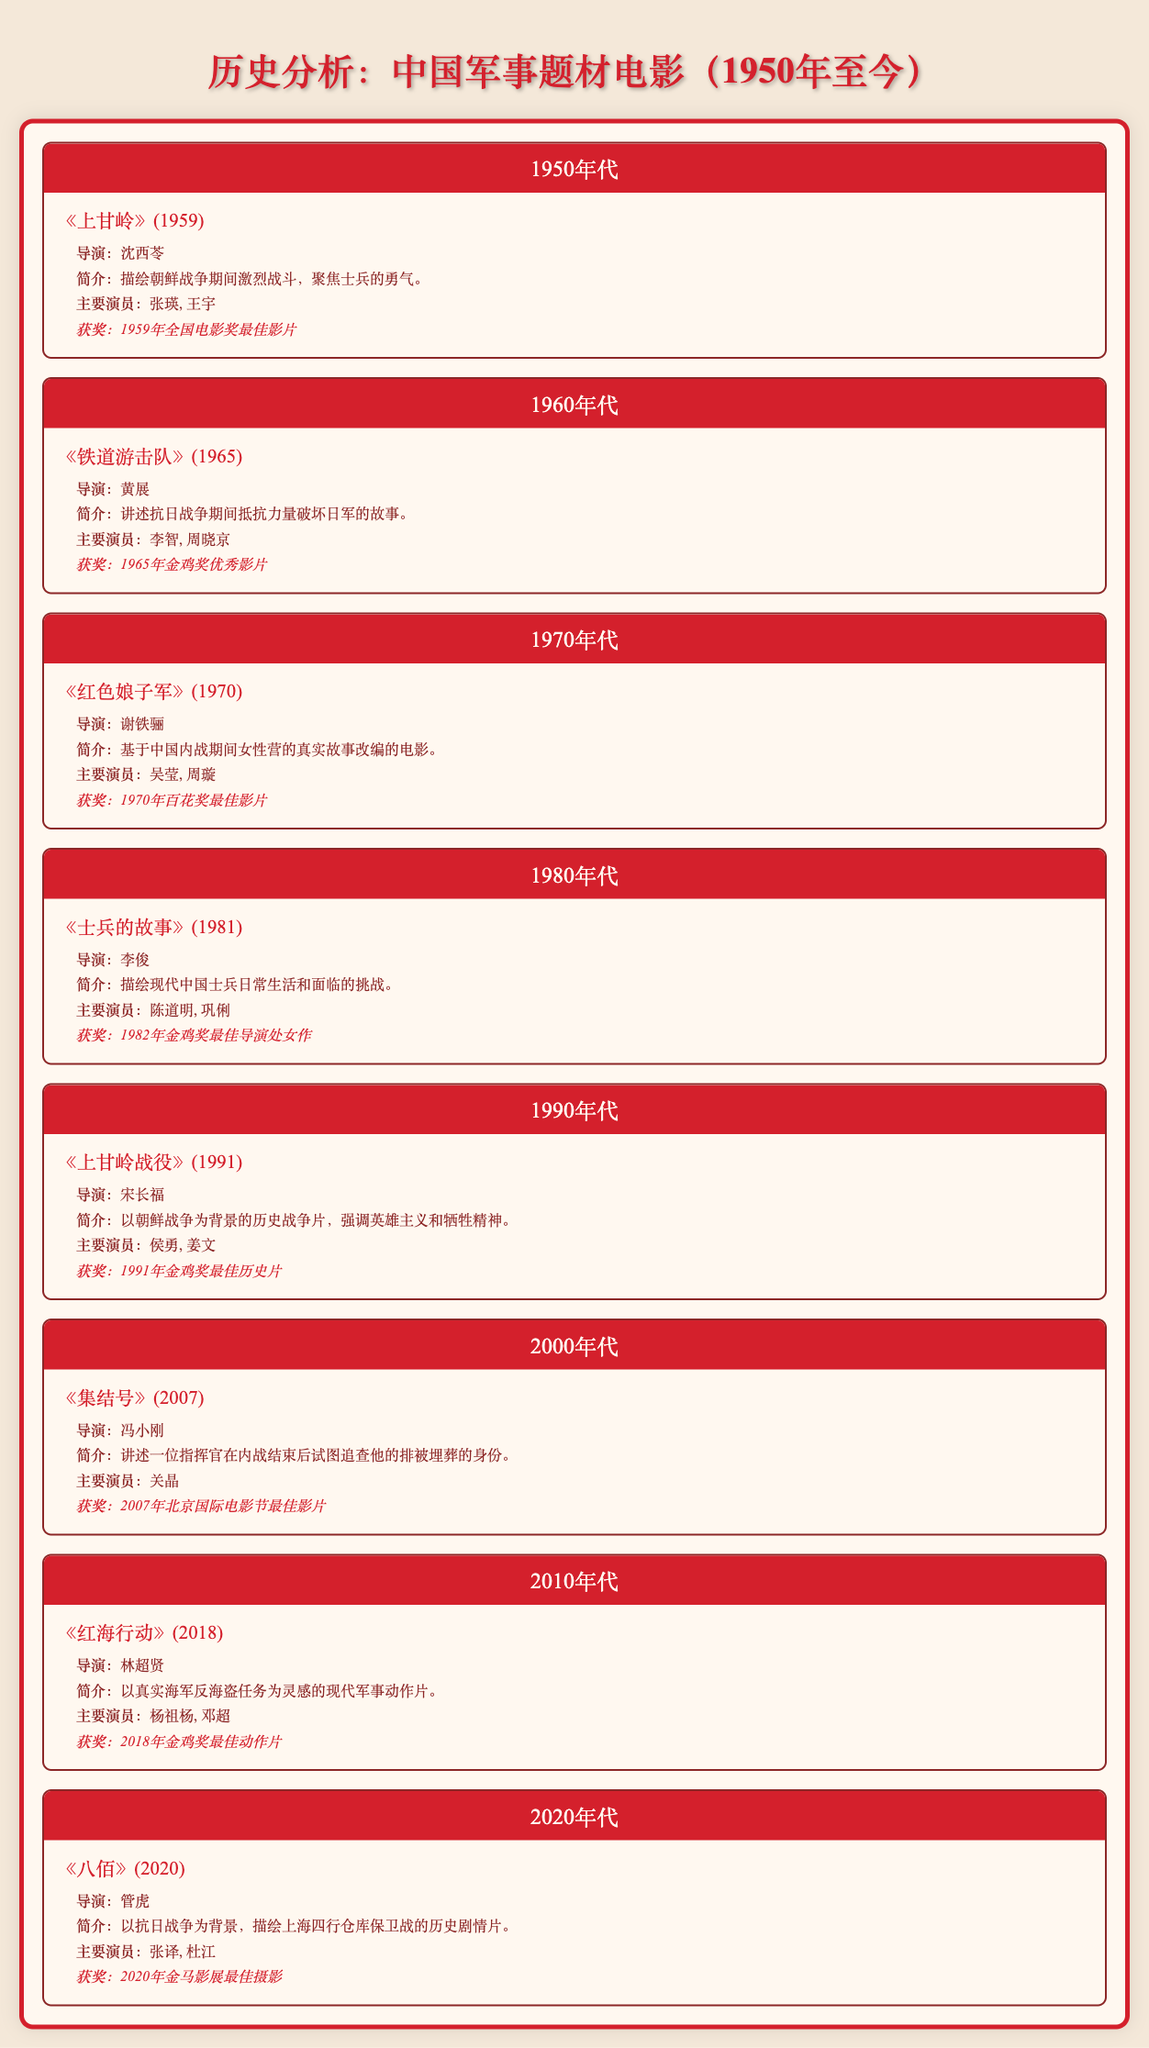What is the title of the military-themed film released in 1959? The table lists the films by decade, and under the 1950s, the film titled "The Battle of Triangle Hill" is presented as the only entry for that year.
Answer: The Battle of Triangle Hill Which film directed by Xie Tieli won an award in the 1970s? By examining the 1970s section, "The Red Detachment of Women" directed by Xie Tieli is noted as the film that won the Best Film award at the 1970 Hundred Flowers Awards.
Answer: The Red Detachment of Women How many awards did "Operation Red Sea" win? According to the table, "Operation Red Sea," released in 2018, won one award, specifically the Best Action Film at the 2018 Golden Rooster Awards.
Answer: One award Which decade featured a film focusing on the experiences of soldiers in modern China? The film "Soldiers' Stories," listed under the 1980s, portrays the everyday lives and challenges faced by soldiers, specifically in modern China.
Answer: 1980s Is "The Eight Hundred" set during the Second Sino-Japanese War? The synopsis for "The Eight Hundred," released in 2020, states it is a historical drama set during the Second Sino-Japanese War, confirming the statement is true.
Answer: Yes What is the average year of release for the films listed from the 2000s? The only film from the 2000s is "Assembly," released in 2007, so the average year is simply 2007, since there is only one data point.
Answer: 2007 Which actor starred in both "The Red Detachment of Women" and "Operation Red Sea"? By scanning the Notable Actors column, no actor is shared between both films; "The Red Detachment of Women" features Wu Ying and Zhou Xuan, while "Operation Red Sea" stars Extreme Yang and Deng Chao.
Answer: None Identify the director of the film "The Battle on Shangganling Mountain." The film "The Battle on Shangganling Mountain" from 1991 is directed by Song Changfu, as provided in the table.
Answer: Song Changfu 